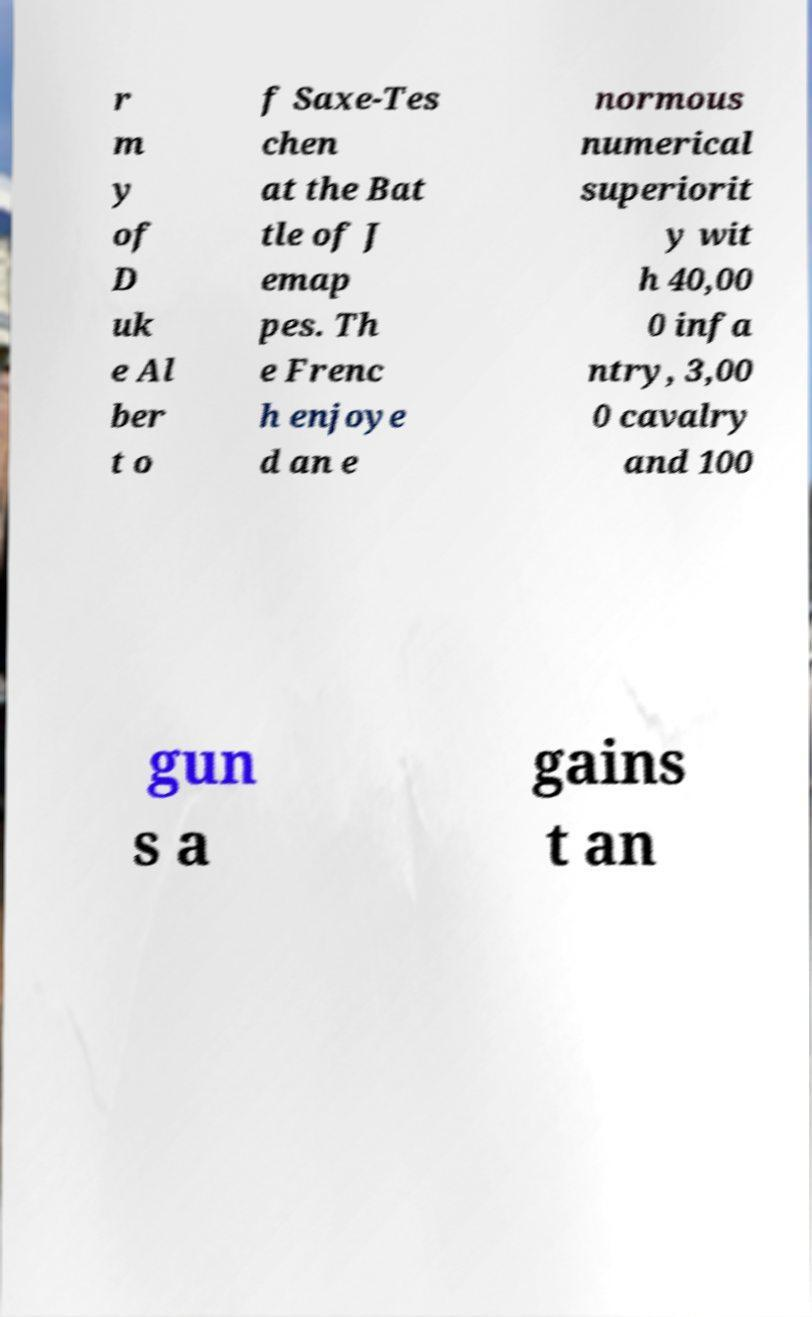Please identify and transcribe the text found in this image. r m y of D uk e Al ber t o f Saxe-Tes chen at the Bat tle of J emap pes. Th e Frenc h enjoye d an e normous numerical superiorit y wit h 40,00 0 infa ntry, 3,00 0 cavalry and 100 gun s a gains t an 